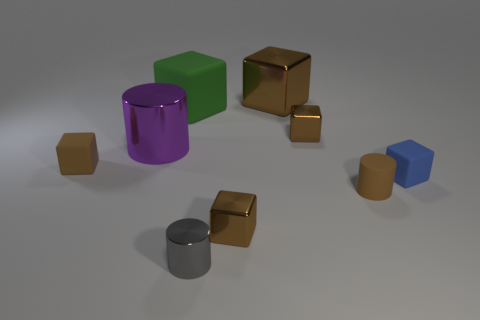Is the big cylinder the same color as the large metallic cube?
Offer a very short reply. No. Are there the same number of metal cubes in front of the green rubber thing and green objects that are in front of the tiny brown matte cylinder?
Offer a very short reply. No. The small matte cylinder has what color?
Provide a short and direct response. Brown. What number of things are either blocks that are right of the large brown cube or large shiny objects?
Keep it short and to the point. 4. There is a brown metallic object that is in front of the brown matte block; is it the same size as the metallic cylinder that is in front of the brown matte cylinder?
Give a very brief answer. Yes. How many objects are brown things that are in front of the brown matte cylinder or tiny brown blocks that are in front of the small brown rubber cube?
Your answer should be very brief. 1. Does the green block have the same material as the big object that is on the left side of the large green cube?
Provide a short and direct response. No. What is the shape of the tiny brown thing that is both on the left side of the big brown metallic block and right of the purple cylinder?
Provide a succinct answer. Cube. What number of other things are there of the same color as the small rubber cylinder?
Ensure brevity in your answer.  4. What is the shape of the green rubber thing?
Offer a very short reply. Cube. 